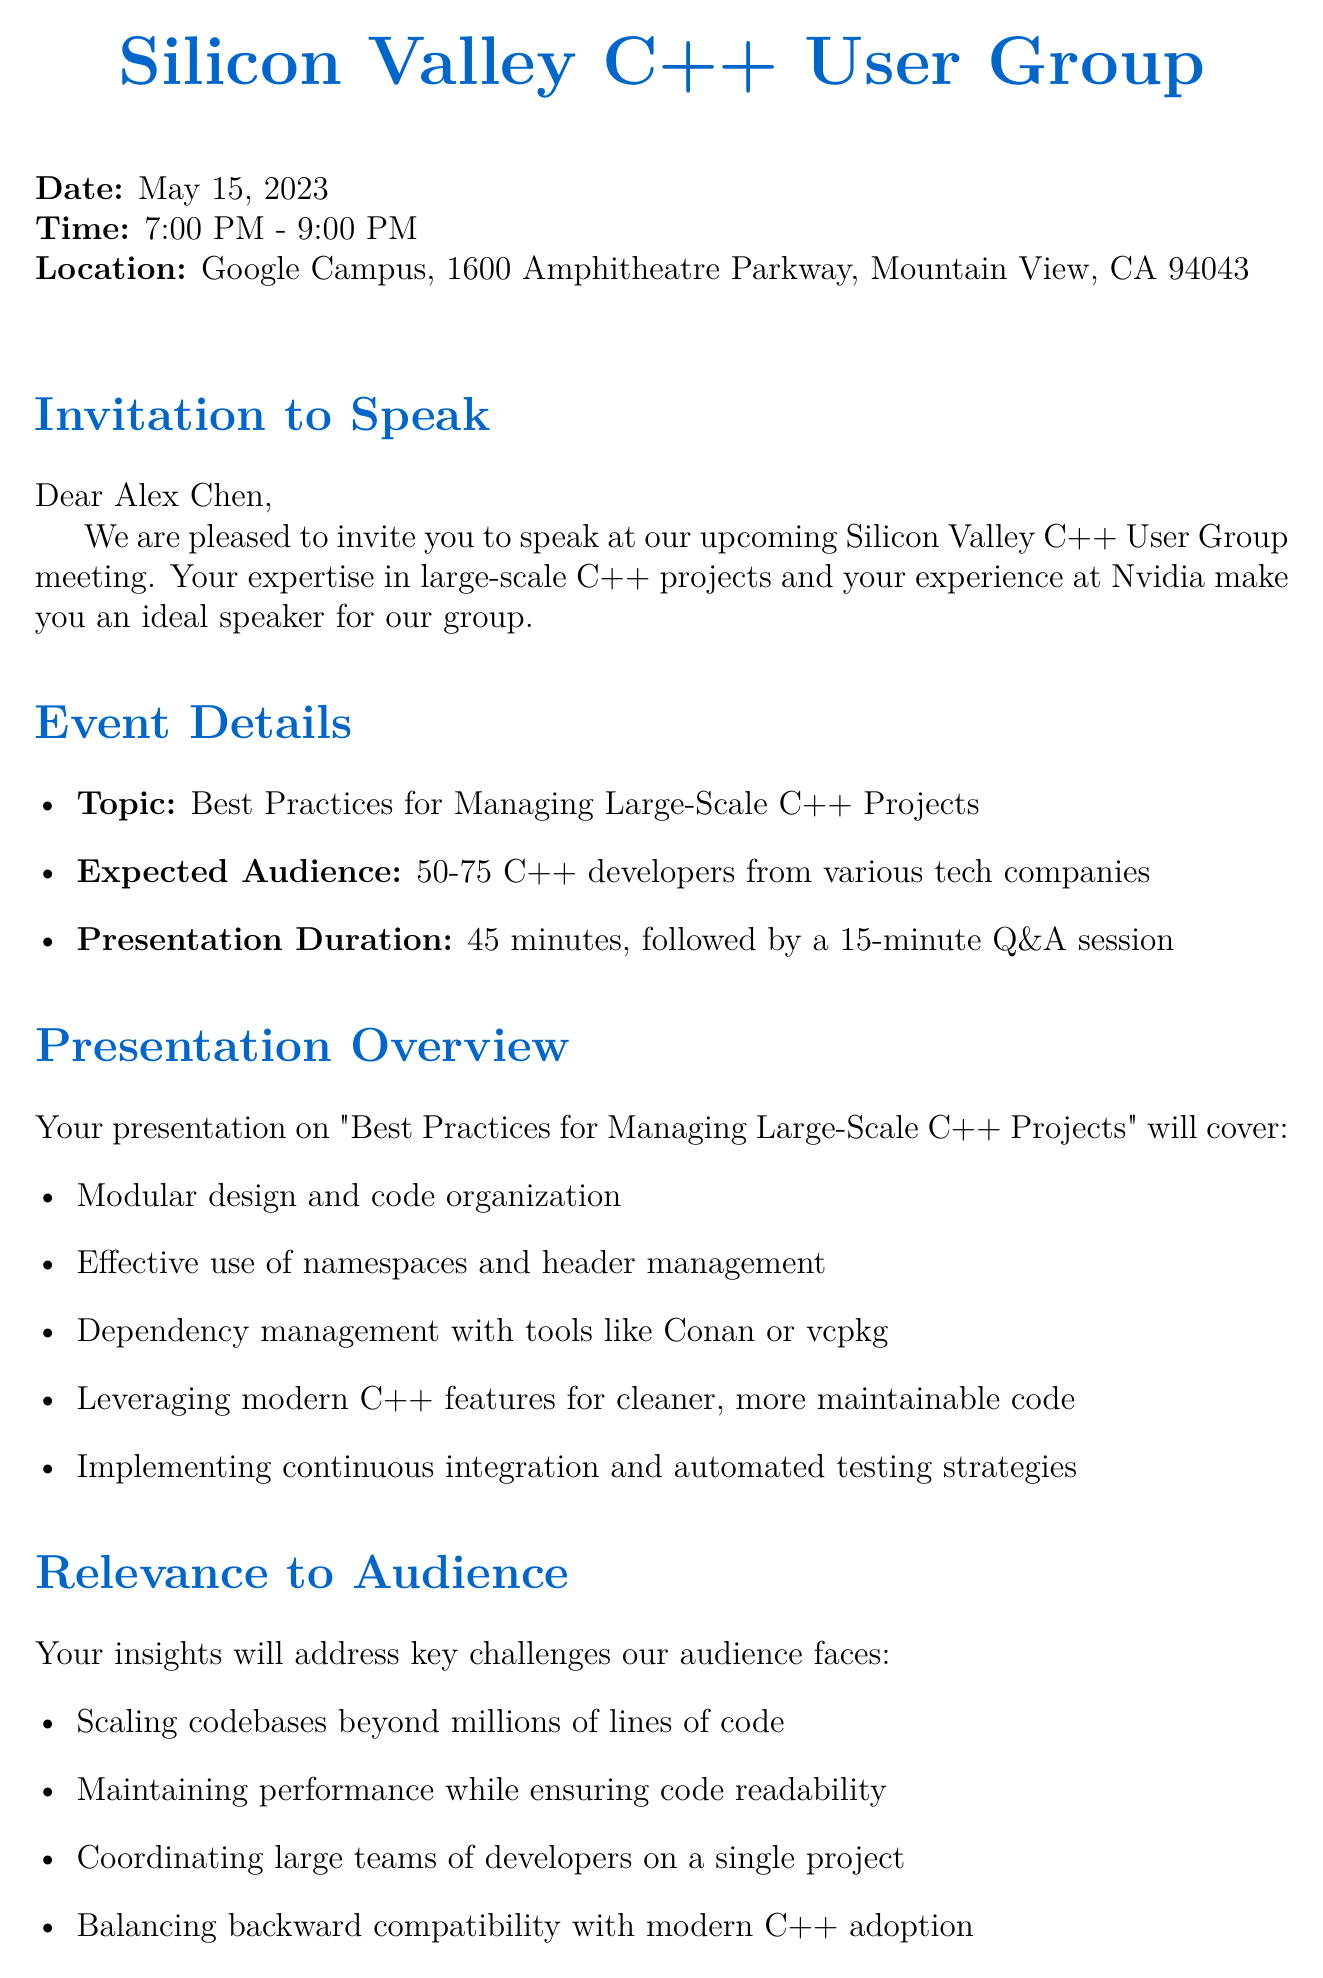what is the date of the event? The date of the event is explicitly stated in the document.
Answer: May 15, 2023 who is the speaker? The speaker's name is mentioned in the invitation letter.
Answer: Alex Chen how long is the presentation? The duration of the presentation is specified in the logistics section of the document.
Answer: 45 minutes what is the expected audience size? The expected audience size is provided as a range in the event details.
Answer: 50-75 C++ developers what additional opportunity is provided during the event? The document mentions an aspect of networking opportunities provided during the event.
Answer: Pre-event mixer what will be provided for the talk? The logistics section lists items that will be available for the speaker during the talk.
Answer: Projector, Microphone, Whiteboard what is the honorarium for the speaker? The honorarium amount is clearly stated in the document.
Answer: $500 which notable projects has the speaker worked on? Notable projects are mentioned in the speaker background section.
Answer: CUDA Toolkit, GeForce Driver Development what is the main topic of the presentation? The topic of the presentation is clearly outlined at the beginning of the presentation overview.
Answer: Best Practices for Managing Large-Scale C++ Projects 